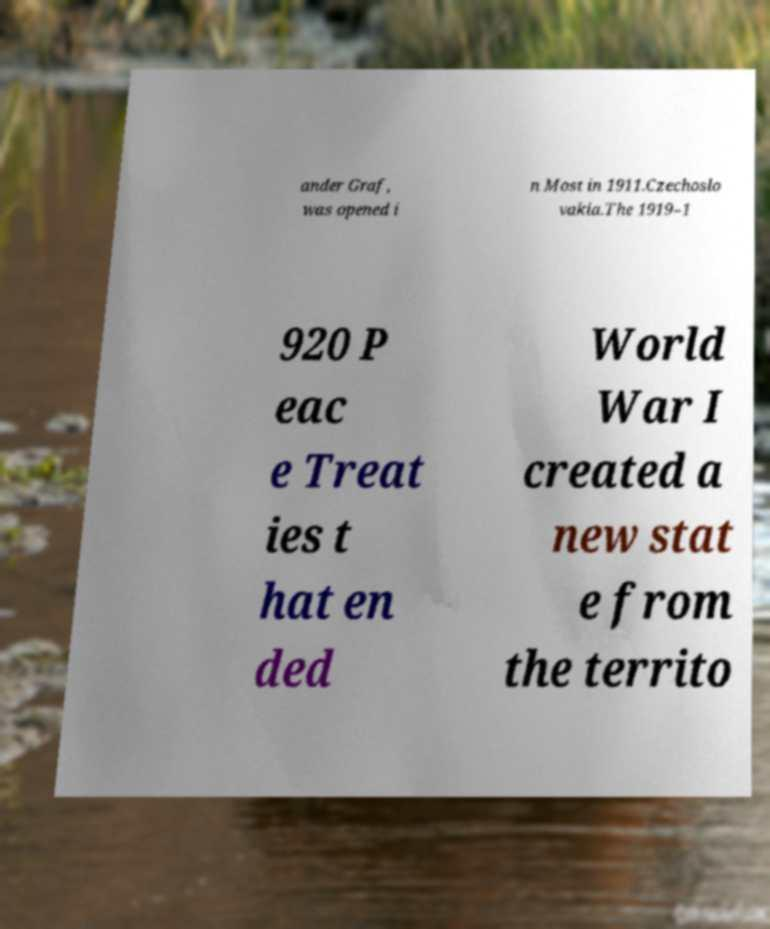Please read and relay the text visible in this image. What does it say? ander Graf, was opened i n Most in 1911.Czechoslo vakia.The 1919–1 920 P eac e Treat ies t hat en ded World War I created a new stat e from the territo 